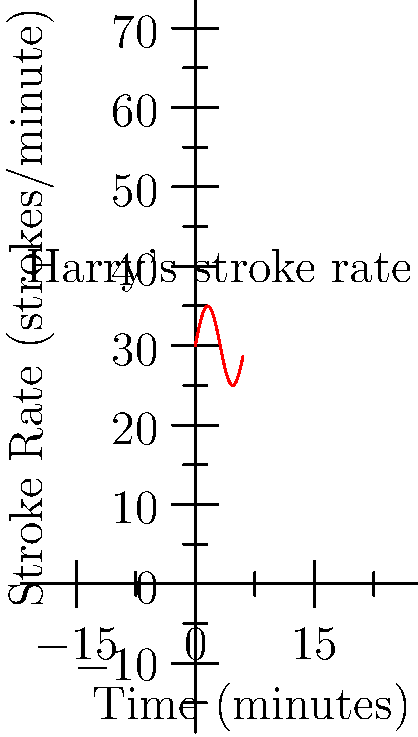During a training session, Harry Brightmore's stroke rate varied as shown in the graph above. If the boat travels 500 meters in total during this 6-minute period, what was the average speed of the boat in meters per second? To solve this problem, we need to follow these steps:

1) First, we need to calculate the average stroke rate:
   The stroke rate oscillates around 30 strokes/minute, with a amplitude of 5 strokes/minute.
   The average stroke rate is the middle value: 30 strokes/minute.

2) However, we don't actually need the stroke rate to calculate the boat's speed.

3) We're given two pieces of important information:
   - Total distance: 500 meters
   - Total time: 6 minutes

4) To calculate average speed, we use the formula:
   $$ \text{Average Speed} = \frac{\text{Total Distance}}{\text{Total Time}} $$

5) We need to convert the time from minutes to seconds:
   $$ 6 \text{ minutes} = 6 \times 60 = 360 \text{ seconds} $$

6) Now we can calculate the average speed:
   $$ \text{Average Speed} = \frac{500 \text{ meters}}{360 \text{ seconds}} = \frac{25}{18} \approx 1.39 \text{ meters/second} $$

Therefore, the average speed of the boat was approximately 1.39 meters per second.
Answer: $\frac{25}{18}$ m/s or approximately 1.39 m/s 